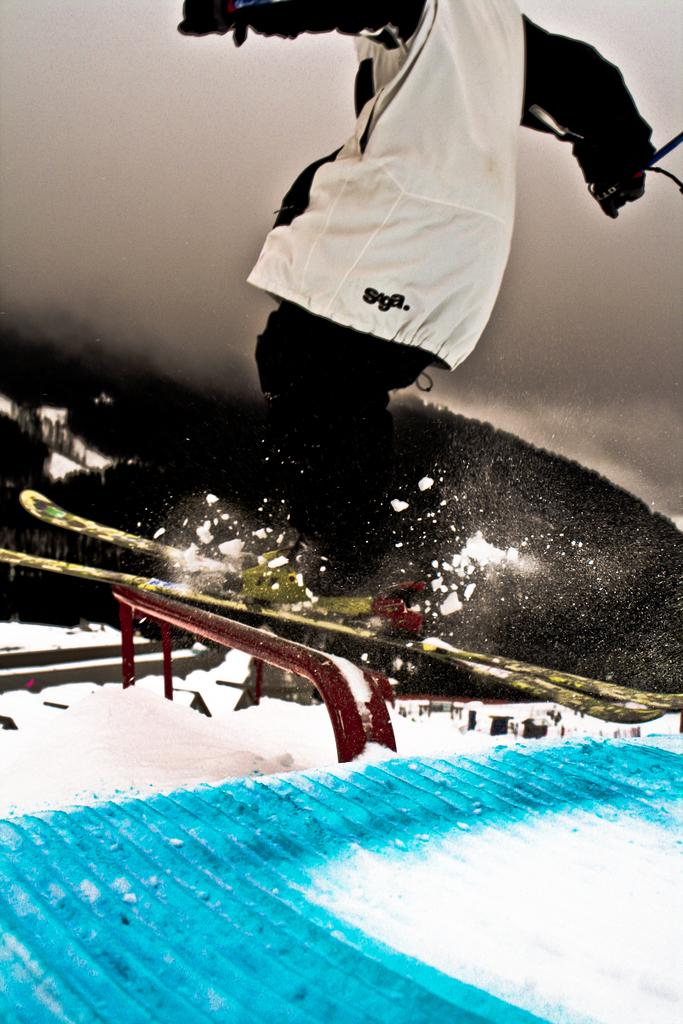What is the main subject of the image? There is a person in the image. What is the person wearing? The person is wearing clothes. What activity is the person engaged in? The person is jumping while snow skiing. What type of terrain can be seen in the image? There is snow visible in the image, and there is a hill in the image. What is visible in the background of the image? The sky is visible in the image. What type of stem can be seen growing from the person's head in the image? There is no stem growing from the person's head in the image. What grade is the person in, as indicated by their clothing? There is no indication of the person's grade based on their clothing in the image. 